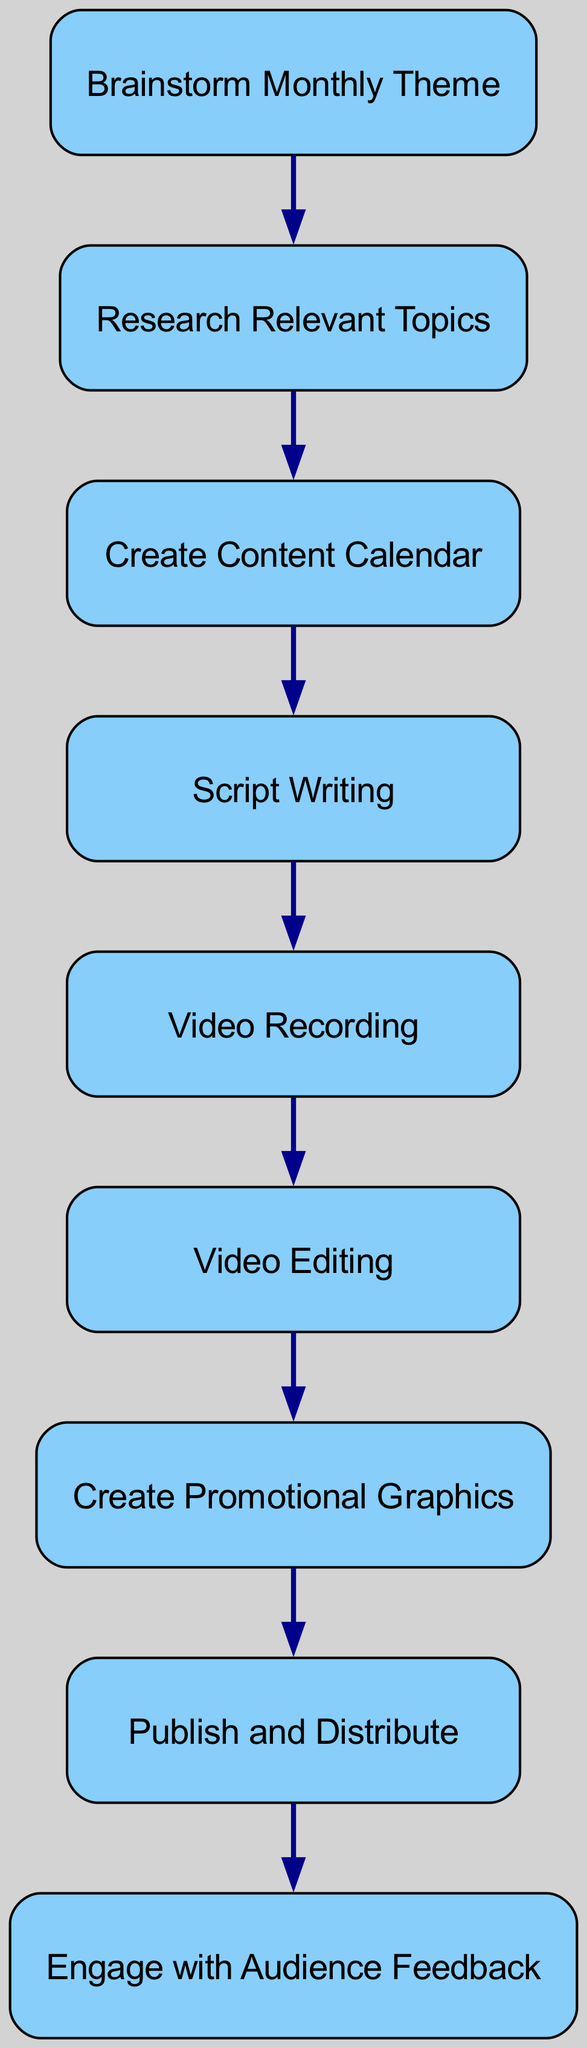What is the first step in the content creation workflow? The diagram indicates that the first node (step) in the workflow is "Brainstorm Monthly Theme," which is where the process begins.
Answer: Brainstorm Monthly Theme How many nodes are there in the diagram? By counting the unique tasks represented as nodes in the diagram, we find there are 9 nodes.
Answer: 9 Which node comes directly after "Script Writing"? The directed edge shows that "Video Recording" is the next node after "Script Writing," indicating the order of tasks in the workflow.
Answer: Video Recording What is the last step in the content creation workflow? The diagram shows that the last node in the sequence, following the final directed edge, is "Engage with Audience Feedback."
Answer: Engage with Audience Feedback How many edges are in the diagram? By counting the connections (edges) between the nodes in the diagram, we see there are 8 edges present.
Answer: 8 Which two nodes have a direct connection between “Create Content Calendar” and “Script Writing”? The direct connection from "Create Content Calendar" to "Script Writing" is shown in the diagram by a directed edge that indicates this specific workflow step.
Answer: Script Writing What follows after "Publish and Distribute"? According to the directed graph, the next step after "Publish and Distribute" is "Engage with Audience Feedback," indicating the conclusion of the publishing phase.
Answer: Engage with Audience Feedback Identify a relationship that involves the first and the last steps in the workflow. The relationship flows from "Brainstorm Monthly Theme" at the beginning, leading through several steps before arriving at the last step, "Engage with Audience Feedback," thus showing a comprehensive workflow from planning to audience engagement.
Answer: Brainstorm Monthly Theme to Engage with Audience Feedback 